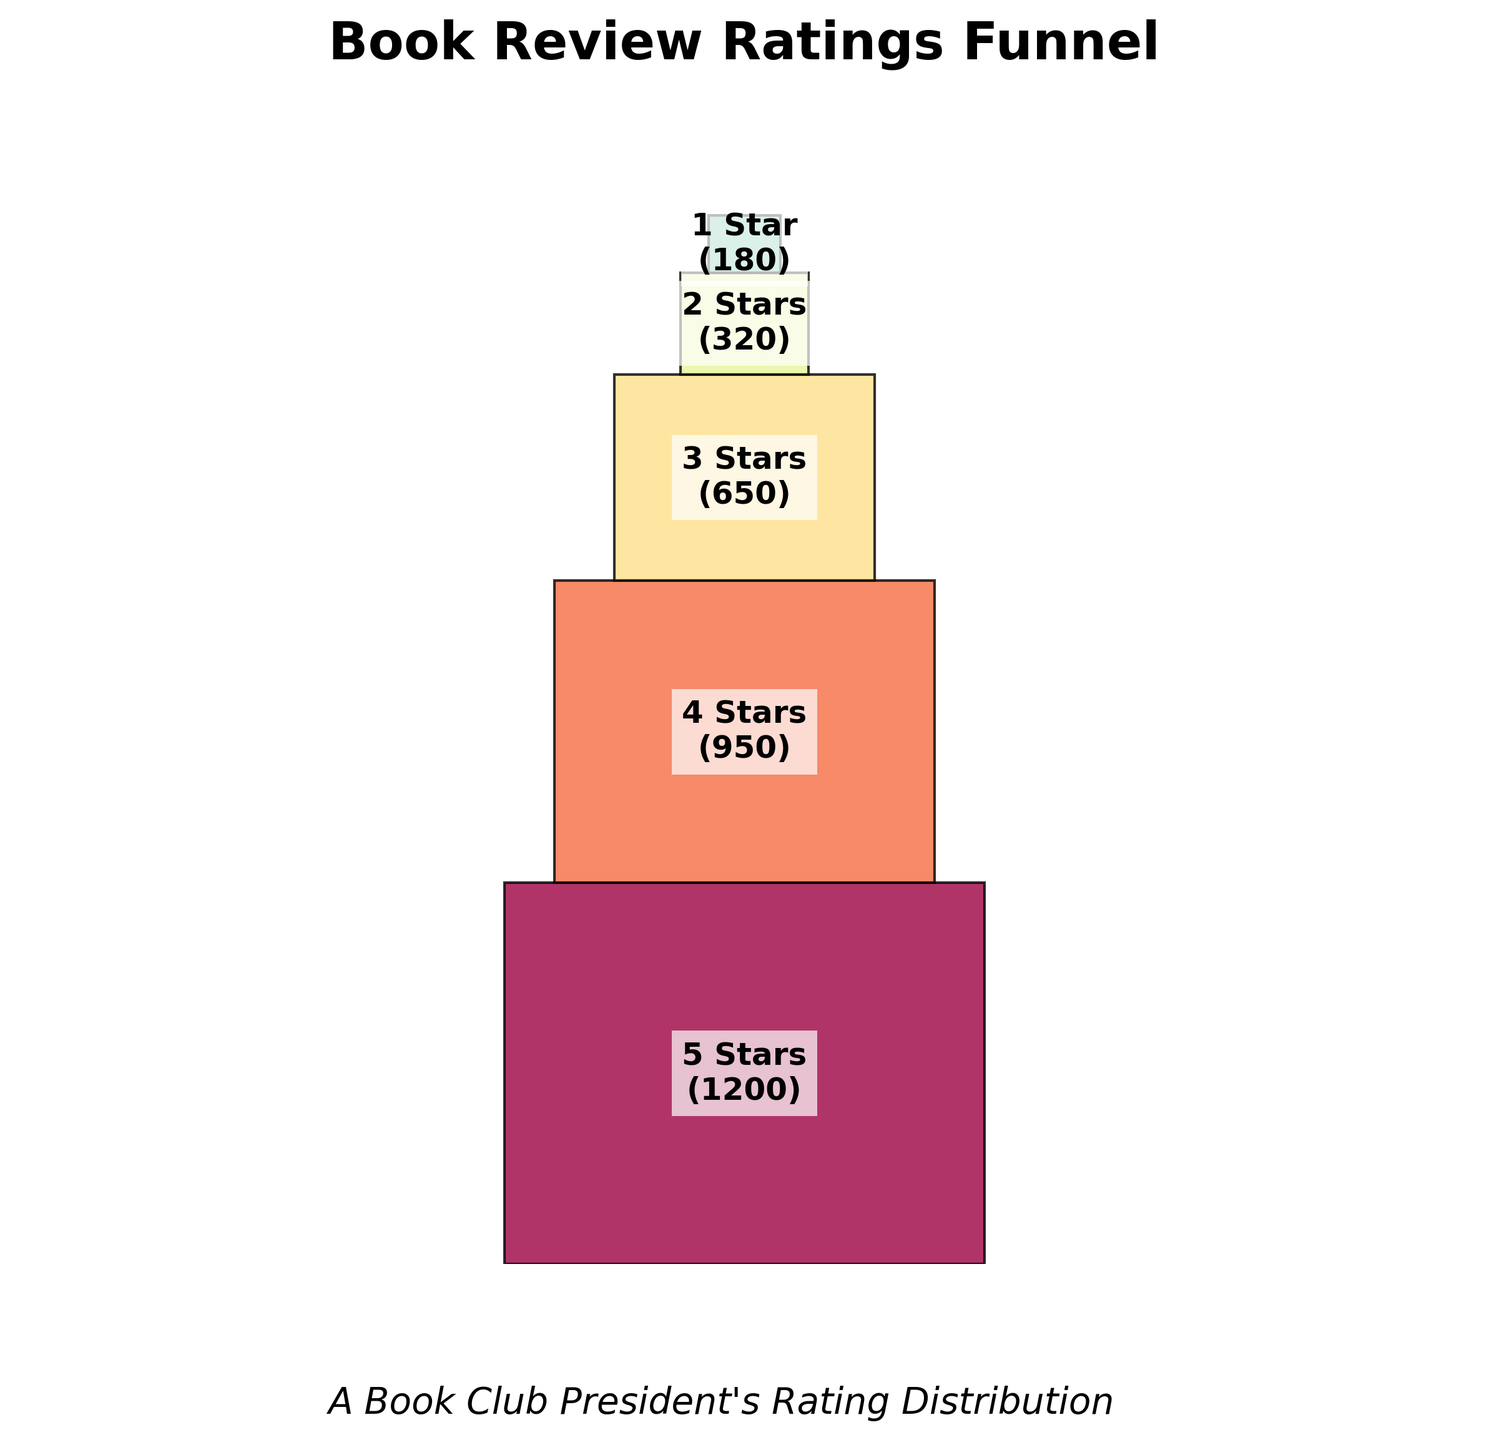What is the title of the funnel chart? The title is usually located at the top of the chart, indicating the main context or subject of the data represented. In this case, it is "Book Review Ratings Funnel"
Answer: Book Review Ratings Funnel Which rating category has the highest count? The segment with the largest width at the top of the funnel represents the highest count, labeled with "5 Stars (1200)"
Answer: 5 Stars How many ratings categories are there in the funnel chart? We can count the number of distinct labels or segments in the funnel chart, which visually indicate different rating categories. Here, we see segments for 5 Stars, 4 Stars, 3 Stars, 2 Stars, and 1 Star
Answer: 5 What is the total number of book reviews represented in the chart? Sum the counts of all rating categories to get the total number: 1200 (5 Stars) + 950 (4 Stars) + 650 (3 Stars) + 320 (2 Stars) + 180 (1 Star)
Answer: 3,300 How does the 3 Stars rating compare with the 1 Star rating in terms of counts? Comparisons involve looking at the counts of 3 Stars and 1 Star: 650 (3 Stars) is greater than 180 (1 Star)
Answer: 3 Stars > 1 Star If you combine the 4 Stars and 3 Stars ratings, how does their total compare to the 5 Stars rating? Calculate the sum of 4 Stars and 3 Stars (950 + 650 = 1600) and compare it to the 5 Stars rating (1200). 1600 is greater than 1200
Answer: Combined > 5 Stars What percentage of the total reviews resulted in 2 Stars ratings? To find the percentage, divide the 2 Stars count (320) by the total (3300) and multiply by 100: (320 / 3300) * 100 ≈ 9.7%
Answer: 9.7% Which rating category appears directly below the 4 Stars segment? By examining the order of segments from top to bottom, the segment directly below 4 Stars (950) is the 3 Stars (650) segment
Answer: 3 Stars How much more common are 5 Stars ratings compared to 2 Stars ratings? Subtract the counts of 2 Stars from 5 Stars: 1200 (5 Stars) - 320 (2 Stars) = 880
Answer: 880 Which two rating categories combined make up the smallest portion of reviews? Add the counts for various pairs to find the smallest total: The combination of 2 Stars (320) and 1 Star (180) gives 320 + 180 = 500, the smallest combined portion
Answer: 2 Stars and 1 Star 